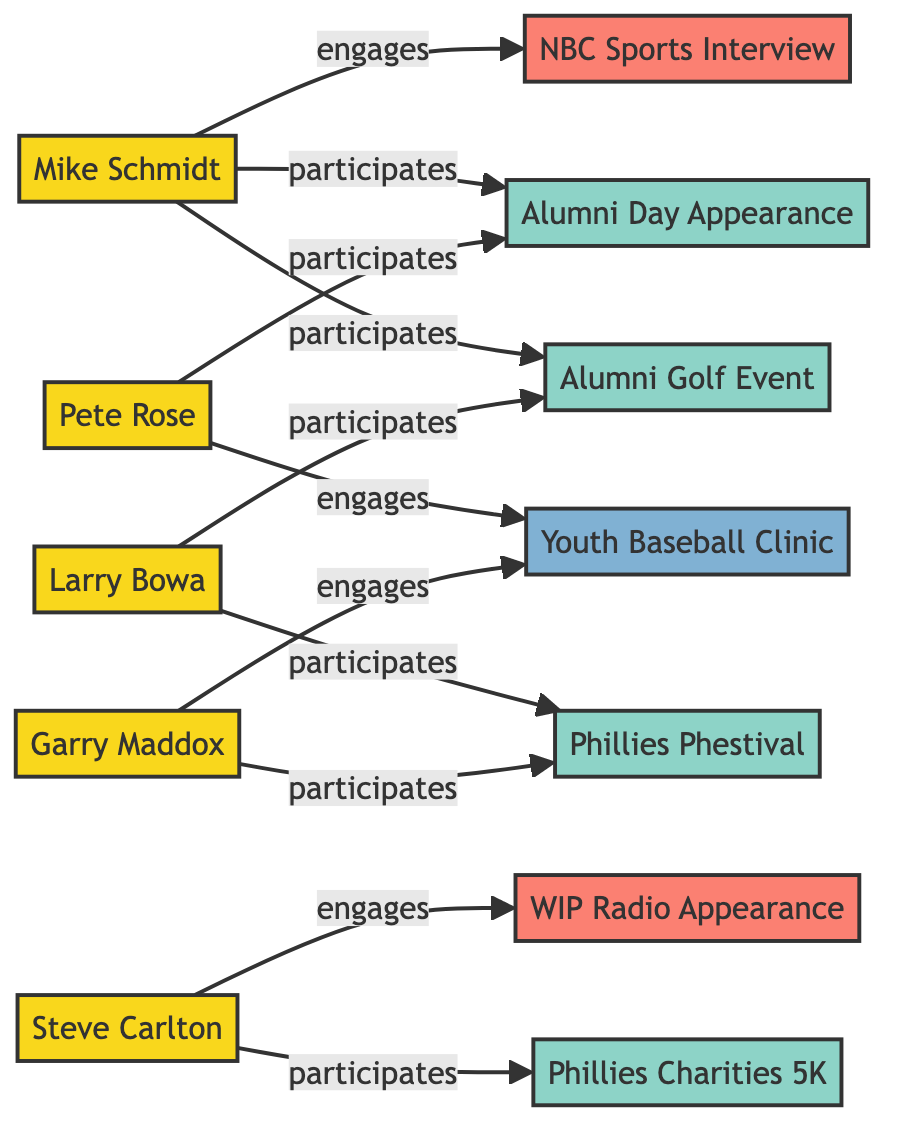What is the total number of players in the diagram? The diagram lists five distinct nodes labeled as players: Mike Schmidt, Steve Carlton, Pete Rose, Larry Bowa, and Garry Maddox. Counting these nodes gives us a total of five players.
Answer: 5 Which event is associated with both Mike Schmidt and Larry Bowa? Observing the participation links, Mike Schmidt is connected to the Alumni Golf Event and Alumni Day Appearance, while Larry Bowa is connected to the Alumni Golf Event as well. Since they share the same connection to this event, it is the answer.
Answer: Alumni Golf Event How many events are represented in the diagram? The nodes list four events: Alumni Golf Event, Phillies Charities 5K, Alumni Day Appearance, Phillies Phestival. Counting these four nodes gives the total number of events in the diagram.
Answer: 4 Which media engagement is Steve Carlton involved in? The diagram indicates that Steve Carlton engages in a radio appearance on WIP. This information is found in the media links specifically connecting Steve Carlton to this engagement.
Answer: Radio Appearance on WIP Which player participates in the Youth Baseball Clinic? Referring to the charitable activity links, Pete Rose is the player engaged in the Youth Baseball Clinic, as shown in the connection from Pete Rose to this charitable activity node.
Answer: Pete Rose Which event has the highest number of participating players? By examining each event's connections, the Phillies Phestival is linked to both Garry Maddox and Larry Bowa, while the Alumni Day Appearance connects Pete Rose and Mike Schmidt, indicating that the Phillies Phestival has the most participants (two players).
Answer: Phillies Phestival 